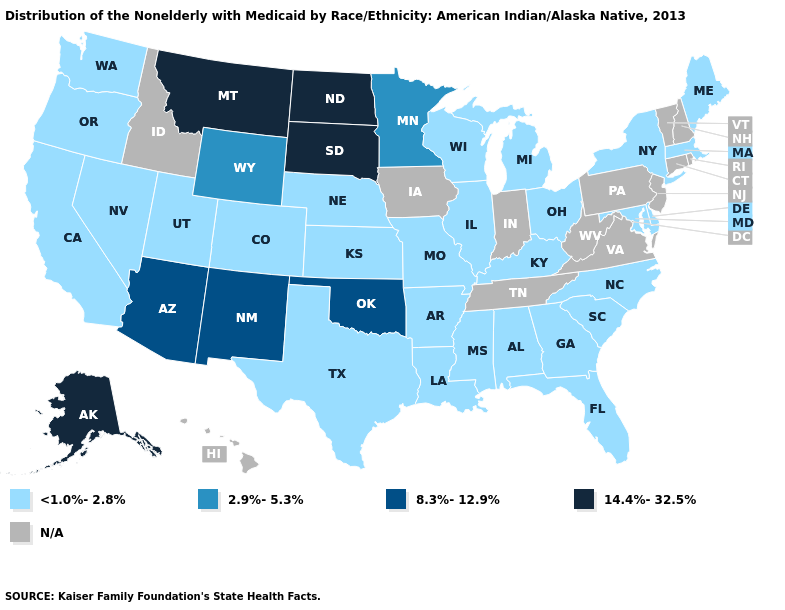What is the lowest value in states that border Arkansas?
Quick response, please. <1.0%-2.8%. Is the legend a continuous bar?
Quick response, please. No. What is the lowest value in the MidWest?
Answer briefly. <1.0%-2.8%. Which states hav the highest value in the South?
Keep it brief. Oklahoma. Among the states that border North Dakota , which have the highest value?
Keep it brief. Montana, South Dakota. Which states have the highest value in the USA?
Quick response, please. Alaska, Montana, North Dakota, South Dakota. What is the value of Massachusetts?
Keep it brief. <1.0%-2.8%. Does the first symbol in the legend represent the smallest category?
Short answer required. Yes. What is the value of Utah?
Answer briefly. <1.0%-2.8%. What is the value of Connecticut?
Concise answer only. N/A. Name the states that have a value in the range 14.4%-32.5%?
Short answer required. Alaska, Montana, North Dakota, South Dakota. Among the states that border New Mexico , does Oklahoma have the lowest value?
Be succinct. No. Does Delaware have the highest value in the South?
Be succinct. No. Does Alaska have the lowest value in the USA?
Concise answer only. No. 